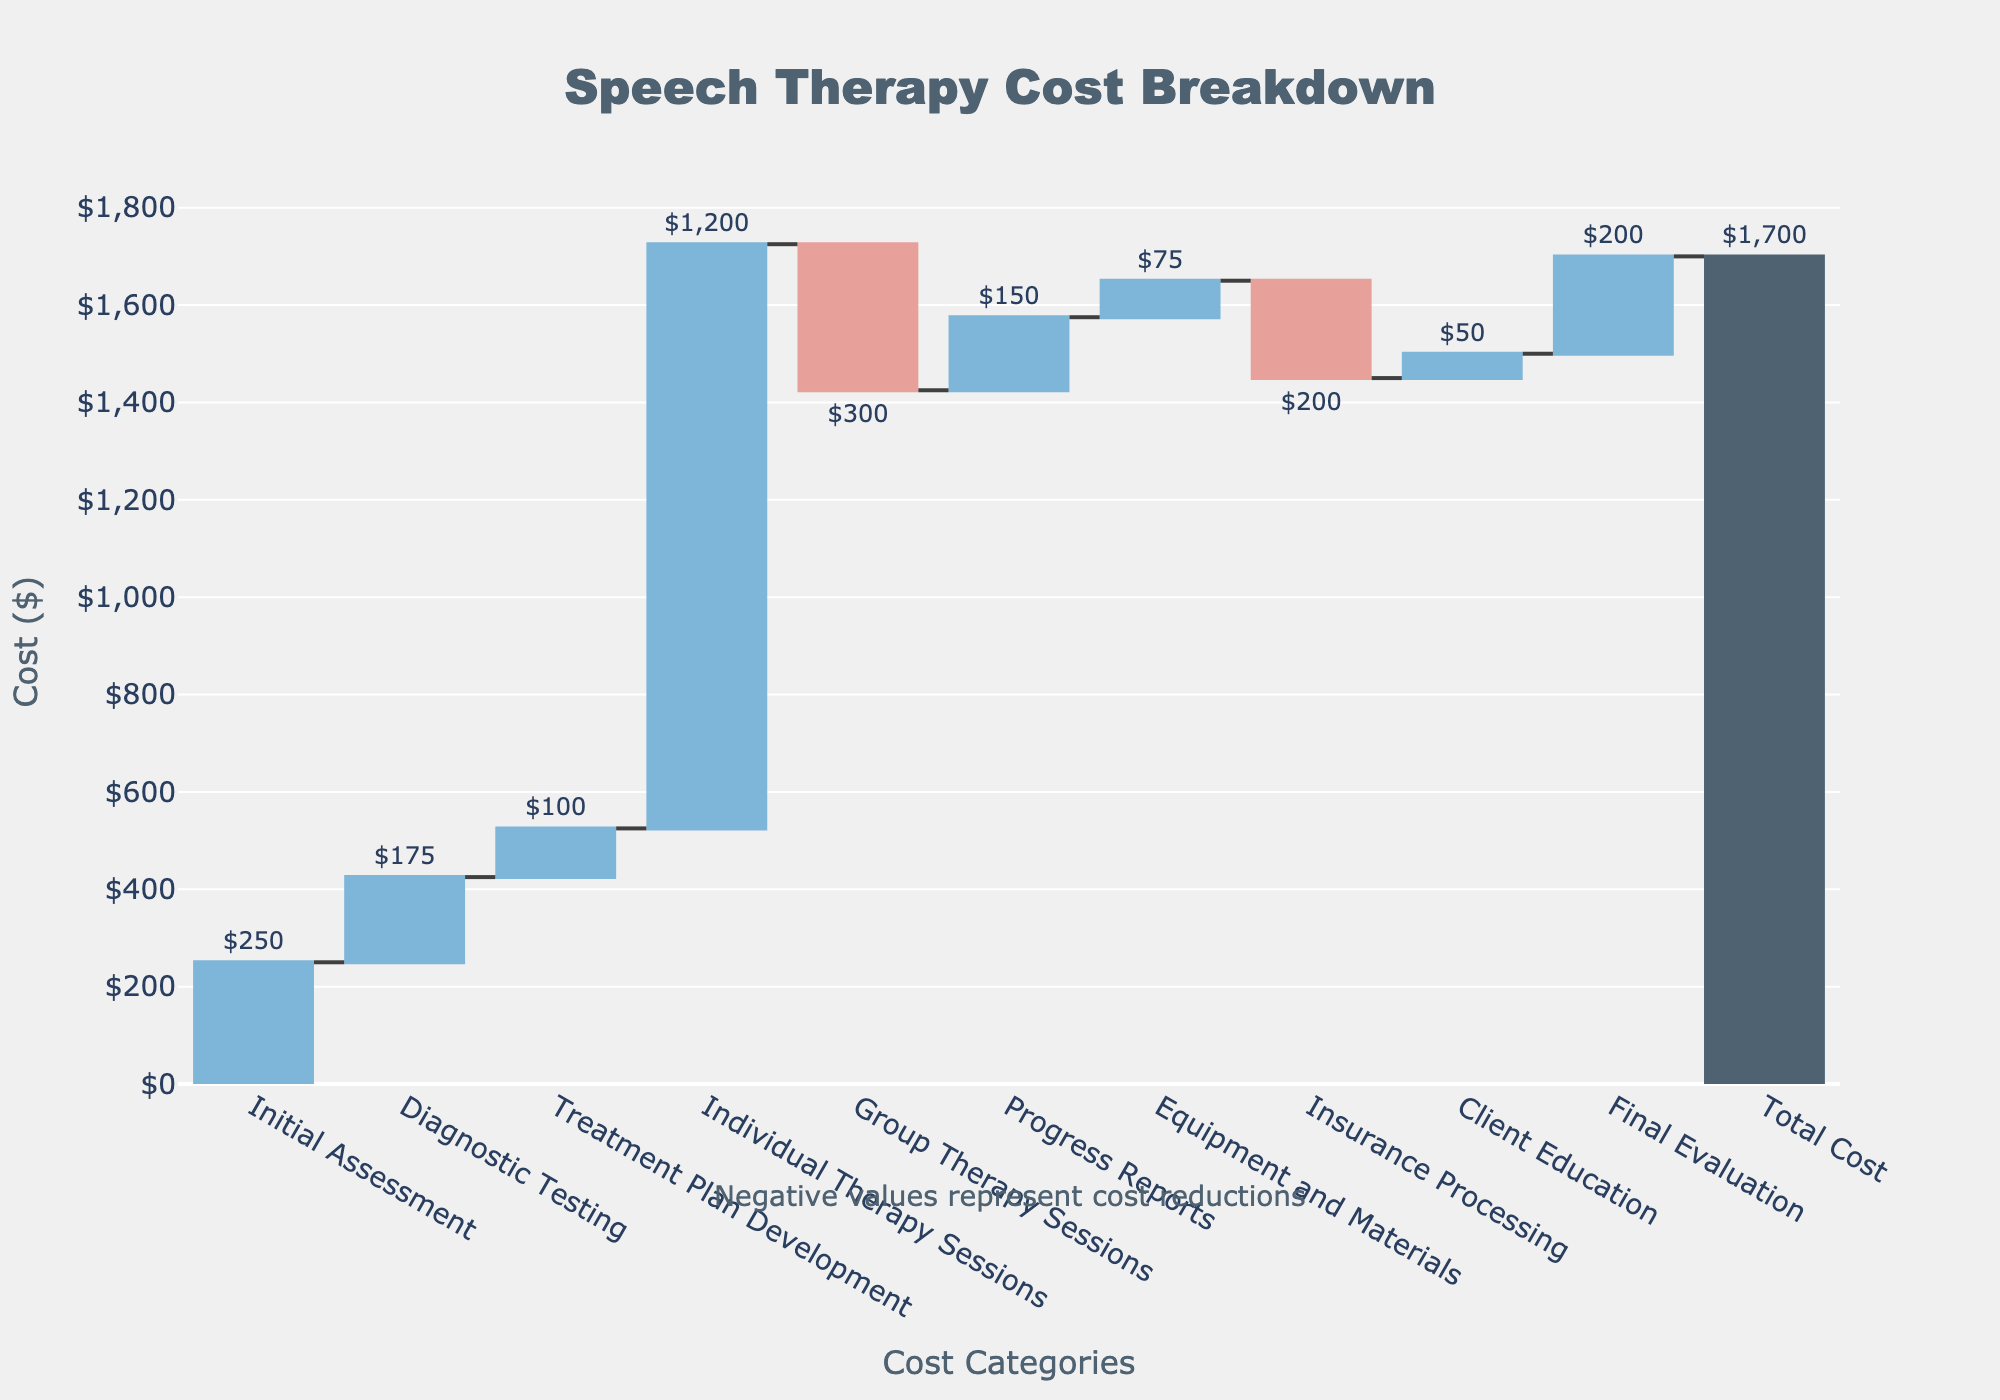What's the total cost of speech therapy sessions? The total cost is located at the end of the Waterfall Chart in the bar labeled "Total Cost." The total cost is $1,700.
Answer: $1,700 What is the initial assessment cost? Look for the bar labeled "Initial Assessment" at the beginning of the chart. It represents a cost of $250.
Answer: $250 Which cost category shows the largest expense? To find the largest expense, compare the heights of the bars with positive values. The "Individual Therapy Sessions" bar is the tallest with a value of $1,200.
Answer: Individual Therapy Sessions What is the net reduction in costs from the "Group Therapy Sessions" and "Insurance Processing"? The net reduction is found by summing the negative values from the "Group Therapy Sessions" (-$300) and "Insurance Processing" (-$200). The calculation is -$300 + -$200 = -$500.
Answer: -$500 How does the cost of "Final Evaluation" compare to "Progress Reports"? Compare the heights of the bars for "Final Evaluation" ($200) and "Progress Reports" ($150). "Final Evaluation" is higher by $50.
Answer: Final Evaluation is $50 higher What is the sum of all the positive costs? Sum the positive values: $250 (Initial Assessment) + $175 (Diagnostic Testing) + $100 (Treatment Plan Development) + $1,200 (Individual Therapy Sessions) + $150 (Progress Reports) + $75 (Equipment and Materials) + $50 (Client Education) + $200 (Final Evaluation). The total is $2,200.
Answer: $2,200 How does "Diagnostic Testing" cost compare to "Client Education"? Look at the bars for "Diagnostic Testing" ($175) and "Client Education" ($50). Diagnostic Testing is $125 more than Client Education.
Answer: $125 more Which cost categories result in deductions? Cost categories with negative bars represent deductions: "Group Therapy Sessions" and "Insurance Processing."
Answer: Group Therapy Sessions, Insurance Processing What is the average cost per category, excluding the total? First, sum all the category costs without including the total ($250 + $175 + $100 + $1,200 + -$300 + $150 + $75 + -$200 + $50 + $200 = $1,700). There are 10 categories, so average cost per category is $1,700 / 10 = $170.
Answer: $170 What do the colors represent in this Waterfall Chart? In a Waterfall Chart, different colors often represent increases, decreases, and totals. Here, blue represents increases in cost, red represents decreases in cost, and gray represents the total cost.
Answer: Increases, decreases, totals 